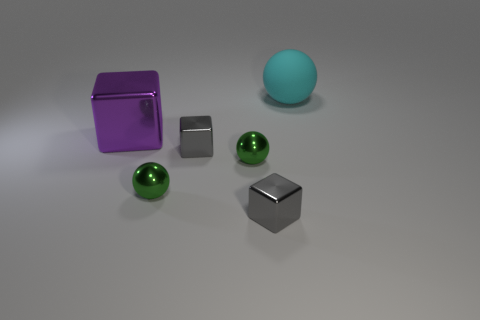Are there any other things that are made of the same material as the cyan ball?
Your response must be concise. No. What number of cyan objects are big balls or large blocks?
Provide a succinct answer. 1. There is a large object that is to the left of the matte thing; what material is it?
Offer a very short reply. Metal. Are there more tiny red cylinders than small shiny objects?
Offer a very short reply. No. How many objects are left of the big cyan thing and to the right of the large purple metallic object?
Give a very brief answer. 4. How many purple metallic objects have the same shape as the large rubber thing?
Your answer should be compact. 0. What color is the object that is behind the big object in front of the cyan sphere?
Provide a short and direct response. Cyan. Does the purple thing have the same shape as the thing that is behind the purple block?
Offer a terse response. No. What material is the large object that is in front of the large thing on the right side of the big object on the left side of the rubber object made of?
Provide a short and direct response. Metal. Are there any green metallic objects of the same size as the cyan matte thing?
Your response must be concise. No. 